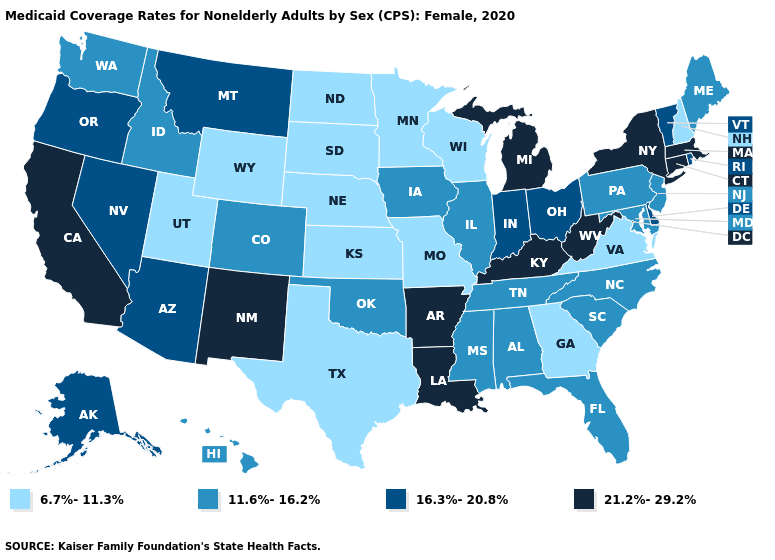Which states have the highest value in the USA?
Give a very brief answer. Arkansas, California, Connecticut, Kentucky, Louisiana, Massachusetts, Michigan, New Mexico, New York, West Virginia. Among the states that border Tennessee , does Mississippi have the lowest value?
Answer briefly. No. Does Nebraska have a lower value than Indiana?
Quick response, please. Yes. Name the states that have a value in the range 21.2%-29.2%?
Write a very short answer. Arkansas, California, Connecticut, Kentucky, Louisiana, Massachusetts, Michigan, New Mexico, New York, West Virginia. Which states have the highest value in the USA?
Give a very brief answer. Arkansas, California, Connecticut, Kentucky, Louisiana, Massachusetts, Michigan, New Mexico, New York, West Virginia. Is the legend a continuous bar?
Keep it brief. No. Among the states that border Arkansas , does Oklahoma have the lowest value?
Quick response, please. No. What is the highest value in the USA?
Concise answer only. 21.2%-29.2%. Does Nebraska have the lowest value in the USA?
Write a very short answer. Yes. What is the highest value in states that border Nevada?
Keep it brief. 21.2%-29.2%. Among the states that border New Hampshire , does Maine have the highest value?
Give a very brief answer. No. What is the value of Missouri?
Write a very short answer. 6.7%-11.3%. What is the value of Alabama?
Short answer required. 11.6%-16.2%. What is the value of Colorado?
Give a very brief answer. 11.6%-16.2%. Name the states that have a value in the range 21.2%-29.2%?
Concise answer only. Arkansas, California, Connecticut, Kentucky, Louisiana, Massachusetts, Michigan, New Mexico, New York, West Virginia. 